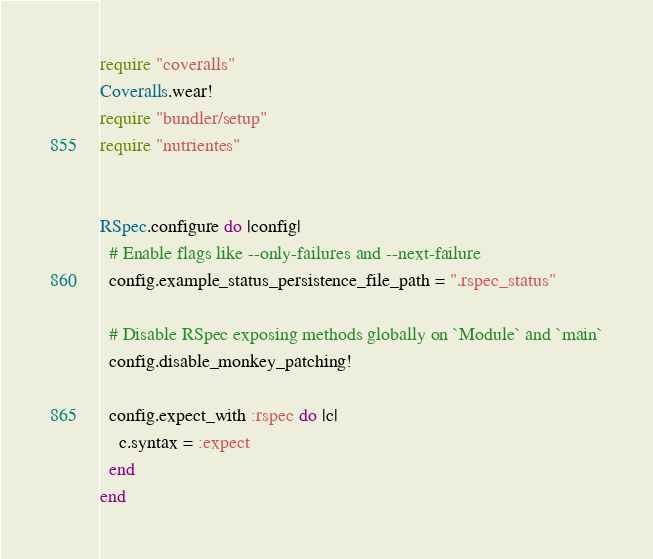Convert code to text. <code><loc_0><loc_0><loc_500><loc_500><_Ruby_>require "coveralls"
Coveralls.wear!
require "bundler/setup"
require "nutrientes"


RSpec.configure do |config|
  # Enable flags like --only-failures and --next-failure
  config.example_status_persistence_file_path = ".rspec_status"

  # Disable RSpec exposing methods globally on `Module` and `main`
  config.disable_monkey_patching!

  config.expect_with :rspec do |c|
    c.syntax = :expect
  end
end
</code> 